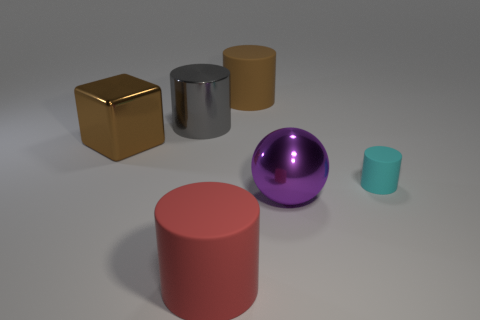The shiny block that is the same size as the metal sphere is what color?
Keep it short and to the point. Brown. Are there any big red rubber objects that have the same shape as the big purple object?
Make the answer very short. No. Is the number of large red cubes less than the number of large red matte objects?
Make the answer very short. Yes. The matte cylinder to the right of the large purple ball is what color?
Your answer should be very brief. Cyan. What shape is the purple thing in front of the block that is in front of the large brown cylinder?
Your answer should be compact. Sphere. Is the material of the big red object the same as the thing that is to the right of the big purple ball?
Your answer should be very brief. Yes. What shape is the object that is the same color as the metal block?
Provide a succinct answer. Cylinder. How many purple metal things are the same size as the brown metal block?
Provide a short and direct response. 1. Are there fewer small cyan rubber cylinders left of the large metallic cube than large gray matte cubes?
Your response must be concise. No. There is a big red cylinder; how many rubber things are behind it?
Your answer should be compact. 2. 